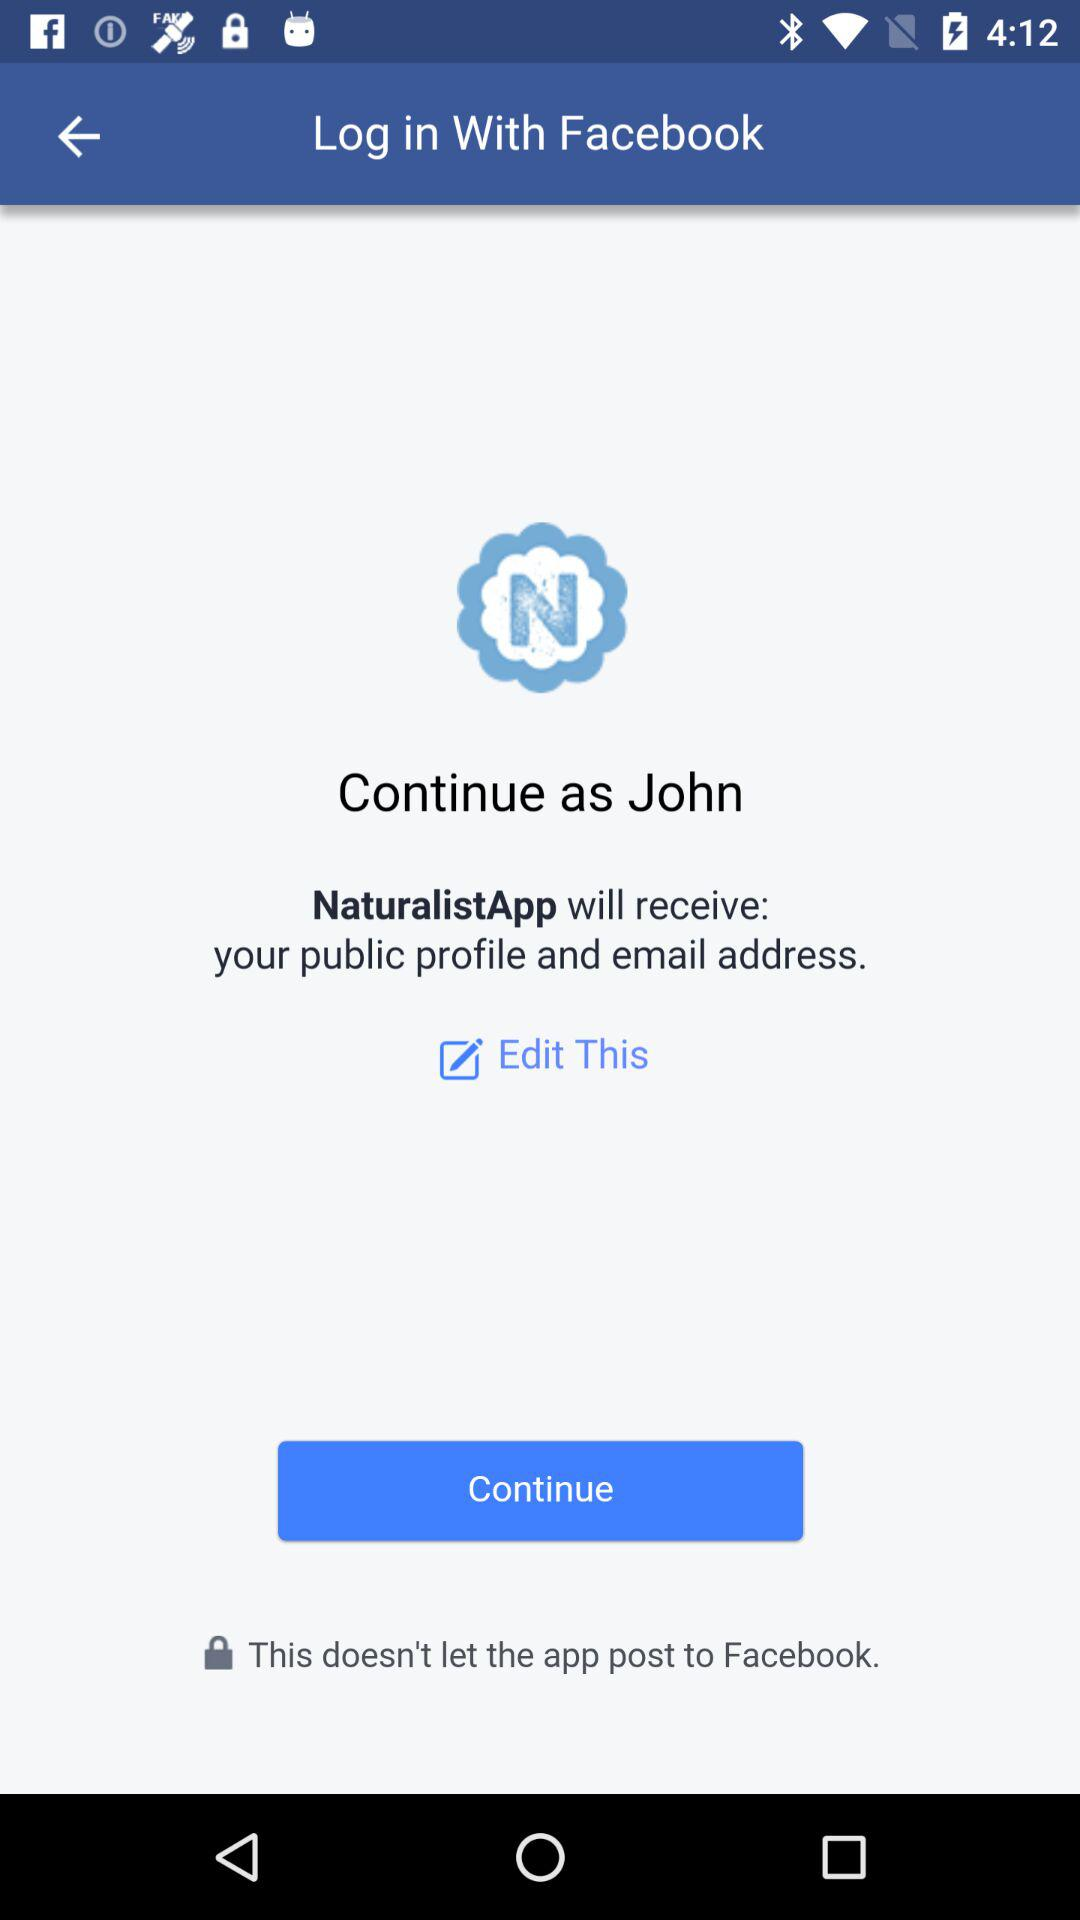What application will receive the public profile and email address? The application that will receive the public profile and email address is "NaturalistApp". 